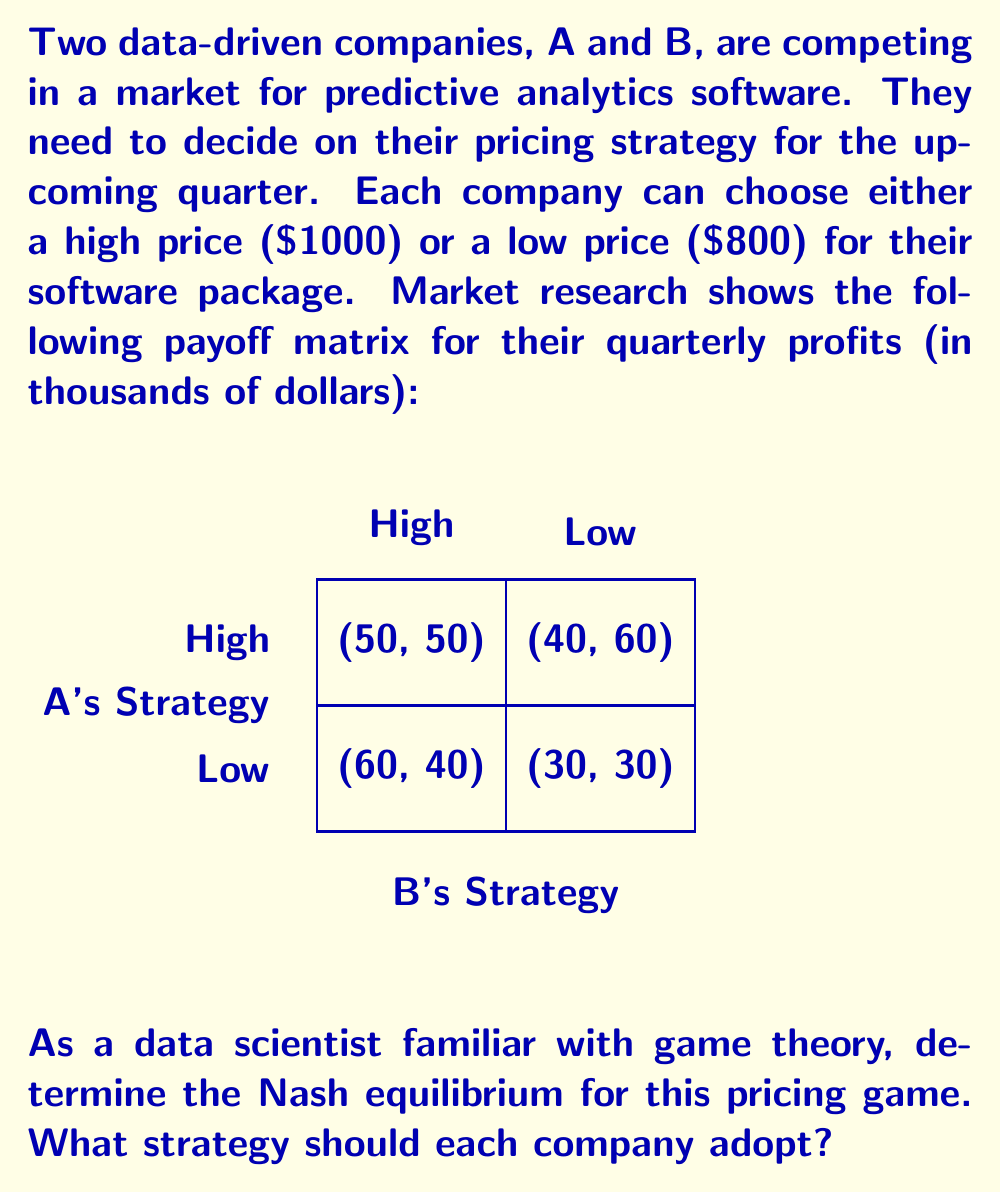Can you answer this question? To solve this game theory problem, we need to find the Nash equilibrium, which is a set of strategies where no player can unilaterally improve their outcome by changing only their own strategy.

Let's analyze the game step-by-step:

1) First, let's consider Company A's perspective:
   - If B chooses High: A gets 50 for High, 60 for Low. A prefers Low.
   - If B chooses Low: A gets 40 for High, 30 for Low. A prefers High.

2) Now, from Company B's perspective:
   - If A chooses High: B gets 50 for High, 40 for Low. B prefers High.
   - If A chooses Low: B gets 60 for High, 30 for Low. B prefers High.

3) We can see that regardless of what A does, B always prefers High. This means High is a dominant strategy for B.

4) Knowing this, A should expect B to play High. In this case, A's best response is to play Low.

5) Therefore, the Nash equilibrium is (Low, High), where A plays Low and B plays High.

6) We can verify this is indeed a Nash equilibrium:
   - If A unilaterally changes to High, its payoff decreases from 60 to 50.
   - If B unilaterally changes to Low, its payoff decreases from 60 to 30.

Thus, neither player has an incentive to unilaterally deviate from this strategy profile.

The equilibrium payoffs are:
$$\text{Payoff}_A = 60, \text{Payoff}_B = 40$$

This solution reflects a common scenario in data-driven markets where one company (B in this case) can maintain a premium pricing strategy due to perceived quality or market position, while the other company (A) adopts a more competitive pricing strategy to gain market share.
Answer: Nash equilibrium: A chooses Low ($800), B chooses High ($1000) 